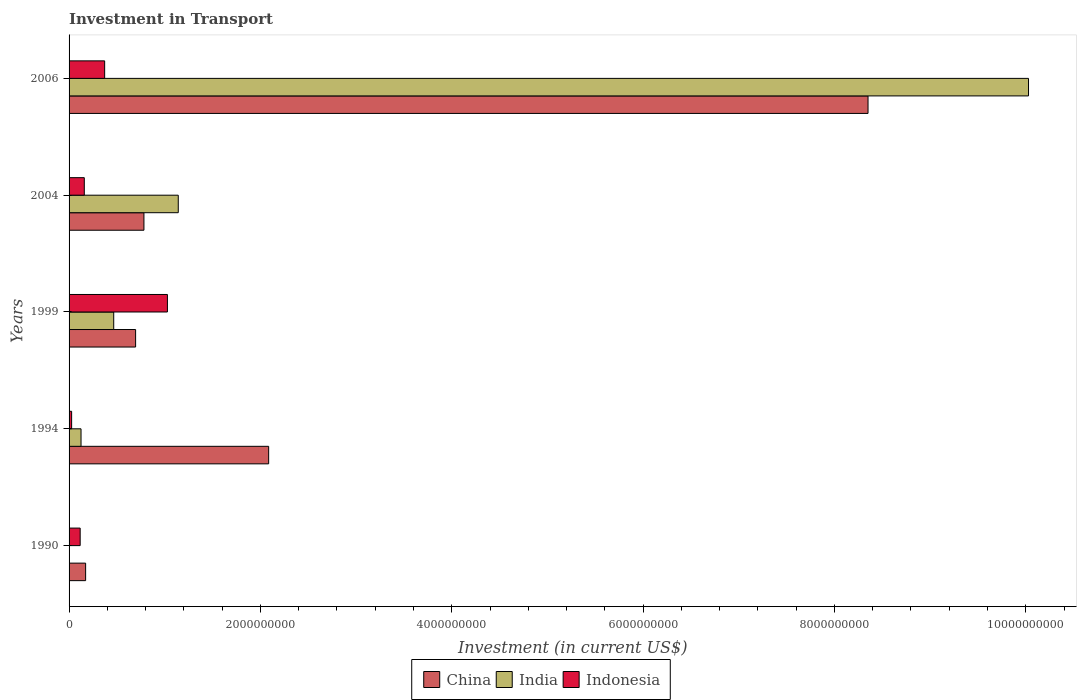How many groups of bars are there?
Keep it short and to the point. 5. Are the number of bars per tick equal to the number of legend labels?
Offer a very short reply. Yes. How many bars are there on the 5th tick from the top?
Give a very brief answer. 3. What is the label of the 3rd group of bars from the top?
Offer a very short reply. 1999. In how many cases, is the number of bars for a given year not equal to the number of legend labels?
Your response must be concise. 0. What is the amount invested in transport in Indonesia in 1999?
Offer a very short reply. 1.03e+09. Across all years, what is the maximum amount invested in transport in India?
Offer a very short reply. 1.00e+1. Across all years, what is the minimum amount invested in transport in Indonesia?
Provide a succinct answer. 2.67e+07. What is the total amount invested in transport in China in the graph?
Provide a succinct answer. 1.21e+1. What is the difference between the amount invested in transport in Indonesia in 1999 and that in 2006?
Ensure brevity in your answer.  6.56e+08. What is the difference between the amount invested in transport in India in 1990 and the amount invested in transport in China in 1994?
Offer a very short reply. -2.08e+09. What is the average amount invested in transport in Indonesia per year?
Provide a succinct answer. 3.40e+08. In the year 2006, what is the difference between the amount invested in transport in Indonesia and amount invested in transport in India?
Offer a terse response. -9.66e+09. In how many years, is the amount invested in transport in India greater than 2800000000 US$?
Give a very brief answer. 1. What is the ratio of the amount invested in transport in Indonesia in 1999 to that in 2004?
Make the answer very short. 6.46. Is the amount invested in transport in India in 1990 less than that in 2004?
Make the answer very short. Yes. What is the difference between the highest and the second highest amount invested in transport in China?
Offer a terse response. 6.26e+09. What is the difference between the highest and the lowest amount invested in transport in China?
Ensure brevity in your answer.  8.18e+09. Is the sum of the amount invested in transport in India in 1994 and 2004 greater than the maximum amount invested in transport in Indonesia across all years?
Your answer should be very brief. Yes. What does the 2nd bar from the bottom in 2004 represents?
Offer a terse response. India. Is it the case that in every year, the sum of the amount invested in transport in Indonesia and amount invested in transport in India is greater than the amount invested in transport in China?
Provide a short and direct response. No. Where does the legend appear in the graph?
Your answer should be very brief. Bottom center. How many legend labels are there?
Keep it short and to the point. 3. How are the legend labels stacked?
Give a very brief answer. Horizontal. What is the title of the graph?
Your answer should be very brief. Investment in Transport. Does "South Asia" appear as one of the legend labels in the graph?
Your response must be concise. No. What is the label or title of the X-axis?
Your response must be concise. Investment (in current US$). What is the label or title of the Y-axis?
Your answer should be compact. Years. What is the Investment (in current US$) in China in 1990?
Your answer should be compact. 1.73e+08. What is the Investment (in current US$) of India in 1990?
Offer a terse response. 1.90e+06. What is the Investment (in current US$) of Indonesia in 1990?
Offer a very short reply. 1.16e+08. What is the Investment (in current US$) in China in 1994?
Ensure brevity in your answer.  2.09e+09. What is the Investment (in current US$) in India in 1994?
Provide a short and direct response. 1.25e+08. What is the Investment (in current US$) of Indonesia in 1994?
Provide a short and direct response. 2.67e+07. What is the Investment (in current US$) in China in 1999?
Your response must be concise. 6.96e+08. What is the Investment (in current US$) of India in 1999?
Offer a terse response. 4.67e+08. What is the Investment (in current US$) of Indonesia in 1999?
Give a very brief answer. 1.03e+09. What is the Investment (in current US$) of China in 2004?
Provide a succinct answer. 7.83e+08. What is the Investment (in current US$) in India in 2004?
Your answer should be very brief. 1.14e+09. What is the Investment (in current US$) of Indonesia in 2004?
Your answer should be compact. 1.59e+08. What is the Investment (in current US$) of China in 2006?
Provide a short and direct response. 8.35e+09. What is the Investment (in current US$) of India in 2006?
Provide a short and direct response. 1.00e+1. What is the Investment (in current US$) of Indonesia in 2006?
Provide a succinct answer. 3.72e+08. Across all years, what is the maximum Investment (in current US$) of China?
Your answer should be very brief. 8.35e+09. Across all years, what is the maximum Investment (in current US$) of India?
Keep it short and to the point. 1.00e+1. Across all years, what is the maximum Investment (in current US$) in Indonesia?
Your response must be concise. 1.03e+09. Across all years, what is the minimum Investment (in current US$) of China?
Your answer should be very brief. 1.73e+08. Across all years, what is the minimum Investment (in current US$) in India?
Make the answer very short. 1.90e+06. Across all years, what is the minimum Investment (in current US$) of Indonesia?
Provide a succinct answer. 2.67e+07. What is the total Investment (in current US$) in China in the graph?
Offer a terse response. 1.21e+1. What is the total Investment (in current US$) of India in the graph?
Give a very brief answer. 1.18e+1. What is the total Investment (in current US$) in Indonesia in the graph?
Offer a terse response. 1.70e+09. What is the difference between the Investment (in current US$) in China in 1990 and that in 1994?
Give a very brief answer. -1.91e+09. What is the difference between the Investment (in current US$) in India in 1990 and that in 1994?
Provide a short and direct response. -1.23e+08. What is the difference between the Investment (in current US$) of Indonesia in 1990 and that in 1994?
Your answer should be compact. 8.93e+07. What is the difference between the Investment (in current US$) of China in 1990 and that in 1999?
Your answer should be compact. -5.23e+08. What is the difference between the Investment (in current US$) of India in 1990 and that in 1999?
Provide a short and direct response. -4.65e+08. What is the difference between the Investment (in current US$) of Indonesia in 1990 and that in 1999?
Offer a terse response. -9.12e+08. What is the difference between the Investment (in current US$) of China in 1990 and that in 2004?
Your answer should be compact. -6.10e+08. What is the difference between the Investment (in current US$) in India in 1990 and that in 2004?
Offer a terse response. -1.14e+09. What is the difference between the Investment (in current US$) in Indonesia in 1990 and that in 2004?
Ensure brevity in your answer.  -4.32e+07. What is the difference between the Investment (in current US$) of China in 1990 and that in 2006?
Offer a terse response. -8.18e+09. What is the difference between the Investment (in current US$) in India in 1990 and that in 2006?
Make the answer very short. -1.00e+1. What is the difference between the Investment (in current US$) in Indonesia in 1990 and that in 2006?
Give a very brief answer. -2.56e+08. What is the difference between the Investment (in current US$) in China in 1994 and that in 1999?
Keep it short and to the point. 1.39e+09. What is the difference between the Investment (in current US$) of India in 1994 and that in 1999?
Offer a very short reply. -3.42e+08. What is the difference between the Investment (in current US$) of Indonesia in 1994 and that in 1999?
Your answer should be very brief. -1.00e+09. What is the difference between the Investment (in current US$) in China in 1994 and that in 2004?
Offer a terse response. 1.30e+09. What is the difference between the Investment (in current US$) of India in 1994 and that in 2004?
Make the answer very short. -1.02e+09. What is the difference between the Investment (in current US$) of Indonesia in 1994 and that in 2004?
Give a very brief answer. -1.32e+08. What is the difference between the Investment (in current US$) of China in 1994 and that in 2006?
Ensure brevity in your answer.  -6.26e+09. What is the difference between the Investment (in current US$) in India in 1994 and that in 2006?
Make the answer very short. -9.90e+09. What is the difference between the Investment (in current US$) of Indonesia in 1994 and that in 2006?
Keep it short and to the point. -3.45e+08. What is the difference between the Investment (in current US$) in China in 1999 and that in 2004?
Provide a short and direct response. -8.70e+07. What is the difference between the Investment (in current US$) in India in 1999 and that in 2004?
Your response must be concise. -6.75e+08. What is the difference between the Investment (in current US$) of Indonesia in 1999 and that in 2004?
Keep it short and to the point. 8.69e+08. What is the difference between the Investment (in current US$) of China in 1999 and that in 2006?
Your answer should be very brief. -7.66e+09. What is the difference between the Investment (in current US$) in India in 1999 and that in 2006?
Offer a terse response. -9.56e+09. What is the difference between the Investment (in current US$) in Indonesia in 1999 and that in 2006?
Ensure brevity in your answer.  6.56e+08. What is the difference between the Investment (in current US$) of China in 2004 and that in 2006?
Your answer should be compact. -7.57e+09. What is the difference between the Investment (in current US$) of India in 2004 and that in 2006?
Keep it short and to the point. -8.89e+09. What is the difference between the Investment (in current US$) in Indonesia in 2004 and that in 2006?
Provide a short and direct response. -2.13e+08. What is the difference between the Investment (in current US$) of China in 1990 and the Investment (in current US$) of India in 1994?
Give a very brief answer. 4.80e+07. What is the difference between the Investment (in current US$) of China in 1990 and the Investment (in current US$) of Indonesia in 1994?
Offer a very short reply. 1.46e+08. What is the difference between the Investment (in current US$) in India in 1990 and the Investment (in current US$) in Indonesia in 1994?
Provide a short and direct response. -2.48e+07. What is the difference between the Investment (in current US$) of China in 1990 and the Investment (in current US$) of India in 1999?
Provide a short and direct response. -2.94e+08. What is the difference between the Investment (in current US$) in China in 1990 and the Investment (in current US$) in Indonesia in 1999?
Your answer should be compact. -8.55e+08. What is the difference between the Investment (in current US$) in India in 1990 and the Investment (in current US$) in Indonesia in 1999?
Offer a terse response. -1.03e+09. What is the difference between the Investment (in current US$) in China in 1990 and the Investment (in current US$) in India in 2004?
Your response must be concise. -9.68e+08. What is the difference between the Investment (in current US$) in China in 1990 and the Investment (in current US$) in Indonesia in 2004?
Your answer should be compact. 1.38e+07. What is the difference between the Investment (in current US$) in India in 1990 and the Investment (in current US$) in Indonesia in 2004?
Your answer should be compact. -1.57e+08. What is the difference between the Investment (in current US$) of China in 1990 and the Investment (in current US$) of India in 2006?
Your answer should be compact. -9.86e+09. What is the difference between the Investment (in current US$) of China in 1990 and the Investment (in current US$) of Indonesia in 2006?
Provide a short and direct response. -1.99e+08. What is the difference between the Investment (in current US$) in India in 1990 and the Investment (in current US$) in Indonesia in 2006?
Give a very brief answer. -3.70e+08. What is the difference between the Investment (in current US$) in China in 1994 and the Investment (in current US$) in India in 1999?
Your response must be concise. 1.62e+09. What is the difference between the Investment (in current US$) in China in 1994 and the Investment (in current US$) in Indonesia in 1999?
Your response must be concise. 1.06e+09. What is the difference between the Investment (in current US$) of India in 1994 and the Investment (in current US$) of Indonesia in 1999?
Offer a terse response. -9.03e+08. What is the difference between the Investment (in current US$) of China in 1994 and the Investment (in current US$) of India in 2004?
Ensure brevity in your answer.  9.45e+08. What is the difference between the Investment (in current US$) in China in 1994 and the Investment (in current US$) in Indonesia in 2004?
Offer a very short reply. 1.93e+09. What is the difference between the Investment (in current US$) in India in 1994 and the Investment (in current US$) in Indonesia in 2004?
Provide a succinct answer. -3.42e+07. What is the difference between the Investment (in current US$) in China in 1994 and the Investment (in current US$) in India in 2006?
Provide a succinct answer. -7.94e+09. What is the difference between the Investment (in current US$) of China in 1994 and the Investment (in current US$) of Indonesia in 2006?
Offer a terse response. 1.71e+09. What is the difference between the Investment (in current US$) in India in 1994 and the Investment (in current US$) in Indonesia in 2006?
Provide a short and direct response. -2.47e+08. What is the difference between the Investment (in current US$) in China in 1999 and the Investment (in current US$) in India in 2004?
Ensure brevity in your answer.  -4.46e+08. What is the difference between the Investment (in current US$) in China in 1999 and the Investment (in current US$) in Indonesia in 2004?
Keep it short and to the point. 5.36e+08. What is the difference between the Investment (in current US$) in India in 1999 and the Investment (in current US$) in Indonesia in 2004?
Your answer should be compact. 3.08e+08. What is the difference between the Investment (in current US$) in China in 1999 and the Investment (in current US$) in India in 2006?
Provide a succinct answer. -9.33e+09. What is the difference between the Investment (in current US$) of China in 1999 and the Investment (in current US$) of Indonesia in 2006?
Provide a short and direct response. 3.24e+08. What is the difference between the Investment (in current US$) in India in 1999 and the Investment (in current US$) in Indonesia in 2006?
Offer a very short reply. 9.47e+07. What is the difference between the Investment (in current US$) in China in 2004 and the Investment (in current US$) in India in 2006?
Your answer should be compact. -9.25e+09. What is the difference between the Investment (in current US$) of China in 2004 and the Investment (in current US$) of Indonesia in 2006?
Offer a terse response. 4.11e+08. What is the difference between the Investment (in current US$) of India in 2004 and the Investment (in current US$) of Indonesia in 2006?
Provide a short and direct response. 7.69e+08. What is the average Investment (in current US$) in China per year?
Offer a very short reply. 2.42e+09. What is the average Investment (in current US$) in India per year?
Provide a succinct answer. 2.35e+09. What is the average Investment (in current US$) of Indonesia per year?
Keep it short and to the point. 3.40e+08. In the year 1990, what is the difference between the Investment (in current US$) in China and Investment (in current US$) in India?
Give a very brief answer. 1.71e+08. In the year 1990, what is the difference between the Investment (in current US$) of China and Investment (in current US$) of Indonesia?
Make the answer very short. 5.70e+07. In the year 1990, what is the difference between the Investment (in current US$) of India and Investment (in current US$) of Indonesia?
Give a very brief answer. -1.14e+08. In the year 1994, what is the difference between the Investment (in current US$) of China and Investment (in current US$) of India?
Provide a succinct answer. 1.96e+09. In the year 1994, what is the difference between the Investment (in current US$) in China and Investment (in current US$) in Indonesia?
Your answer should be compact. 2.06e+09. In the year 1994, what is the difference between the Investment (in current US$) of India and Investment (in current US$) of Indonesia?
Ensure brevity in your answer.  9.83e+07. In the year 1999, what is the difference between the Investment (in current US$) in China and Investment (in current US$) in India?
Ensure brevity in your answer.  2.29e+08. In the year 1999, what is the difference between the Investment (in current US$) of China and Investment (in current US$) of Indonesia?
Ensure brevity in your answer.  -3.32e+08. In the year 1999, what is the difference between the Investment (in current US$) in India and Investment (in current US$) in Indonesia?
Provide a short and direct response. -5.61e+08. In the year 2004, what is the difference between the Investment (in current US$) of China and Investment (in current US$) of India?
Offer a terse response. -3.59e+08. In the year 2004, what is the difference between the Investment (in current US$) in China and Investment (in current US$) in Indonesia?
Make the answer very short. 6.23e+08. In the year 2004, what is the difference between the Investment (in current US$) of India and Investment (in current US$) of Indonesia?
Provide a short and direct response. 9.82e+08. In the year 2006, what is the difference between the Investment (in current US$) of China and Investment (in current US$) of India?
Provide a succinct answer. -1.68e+09. In the year 2006, what is the difference between the Investment (in current US$) in China and Investment (in current US$) in Indonesia?
Give a very brief answer. 7.98e+09. In the year 2006, what is the difference between the Investment (in current US$) of India and Investment (in current US$) of Indonesia?
Offer a terse response. 9.66e+09. What is the ratio of the Investment (in current US$) of China in 1990 to that in 1994?
Provide a succinct answer. 0.08. What is the ratio of the Investment (in current US$) of India in 1990 to that in 1994?
Your answer should be very brief. 0.02. What is the ratio of the Investment (in current US$) of Indonesia in 1990 to that in 1994?
Offer a terse response. 4.34. What is the ratio of the Investment (in current US$) in China in 1990 to that in 1999?
Provide a succinct answer. 0.25. What is the ratio of the Investment (in current US$) of India in 1990 to that in 1999?
Ensure brevity in your answer.  0. What is the ratio of the Investment (in current US$) in Indonesia in 1990 to that in 1999?
Offer a terse response. 0.11. What is the ratio of the Investment (in current US$) in China in 1990 to that in 2004?
Give a very brief answer. 0.22. What is the ratio of the Investment (in current US$) of India in 1990 to that in 2004?
Your answer should be compact. 0. What is the ratio of the Investment (in current US$) of Indonesia in 1990 to that in 2004?
Give a very brief answer. 0.73. What is the ratio of the Investment (in current US$) of China in 1990 to that in 2006?
Offer a very short reply. 0.02. What is the ratio of the Investment (in current US$) in India in 1990 to that in 2006?
Your answer should be very brief. 0. What is the ratio of the Investment (in current US$) of Indonesia in 1990 to that in 2006?
Your answer should be compact. 0.31. What is the ratio of the Investment (in current US$) of China in 1994 to that in 1999?
Make the answer very short. 3. What is the ratio of the Investment (in current US$) of India in 1994 to that in 1999?
Provide a short and direct response. 0.27. What is the ratio of the Investment (in current US$) in Indonesia in 1994 to that in 1999?
Offer a very short reply. 0.03. What is the ratio of the Investment (in current US$) of China in 1994 to that in 2004?
Give a very brief answer. 2.67. What is the ratio of the Investment (in current US$) of India in 1994 to that in 2004?
Your answer should be very brief. 0.11. What is the ratio of the Investment (in current US$) of Indonesia in 1994 to that in 2004?
Ensure brevity in your answer.  0.17. What is the ratio of the Investment (in current US$) of China in 1994 to that in 2006?
Your response must be concise. 0.25. What is the ratio of the Investment (in current US$) of India in 1994 to that in 2006?
Your answer should be very brief. 0.01. What is the ratio of the Investment (in current US$) of Indonesia in 1994 to that in 2006?
Make the answer very short. 0.07. What is the ratio of the Investment (in current US$) of China in 1999 to that in 2004?
Provide a succinct answer. 0.89. What is the ratio of the Investment (in current US$) of India in 1999 to that in 2004?
Your answer should be very brief. 0.41. What is the ratio of the Investment (in current US$) of Indonesia in 1999 to that in 2004?
Provide a succinct answer. 6.46. What is the ratio of the Investment (in current US$) in China in 1999 to that in 2006?
Provide a succinct answer. 0.08. What is the ratio of the Investment (in current US$) in India in 1999 to that in 2006?
Your answer should be very brief. 0.05. What is the ratio of the Investment (in current US$) in Indonesia in 1999 to that in 2006?
Offer a very short reply. 2.76. What is the ratio of the Investment (in current US$) of China in 2004 to that in 2006?
Keep it short and to the point. 0.09. What is the ratio of the Investment (in current US$) of India in 2004 to that in 2006?
Provide a succinct answer. 0.11. What is the ratio of the Investment (in current US$) of Indonesia in 2004 to that in 2006?
Offer a terse response. 0.43. What is the difference between the highest and the second highest Investment (in current US$) in China?
Keep it short and to the point. 6.26e+09. What is the difference between the highest and the second highest Investment (in current US$) of India?
Ensure brevity in your answer.  8.89e+09. What is the difference between the highest and the second highest Investment (in current US$) in Indonesia?
Make the answer very short. 6.56e+08. What is the difference between the highest and the lowest Investment (in current US$) in China?
Offer a terse response. 8.18e+09. What is the difference between the highest and the lowest Investment (in current US$) of India?
Provide a short and direct response. 1.00e+1. What is the difference between the highest and the lowest Investment (in current US$) of Indonesia?
Keep it short and to the point. 1.00e+09. 